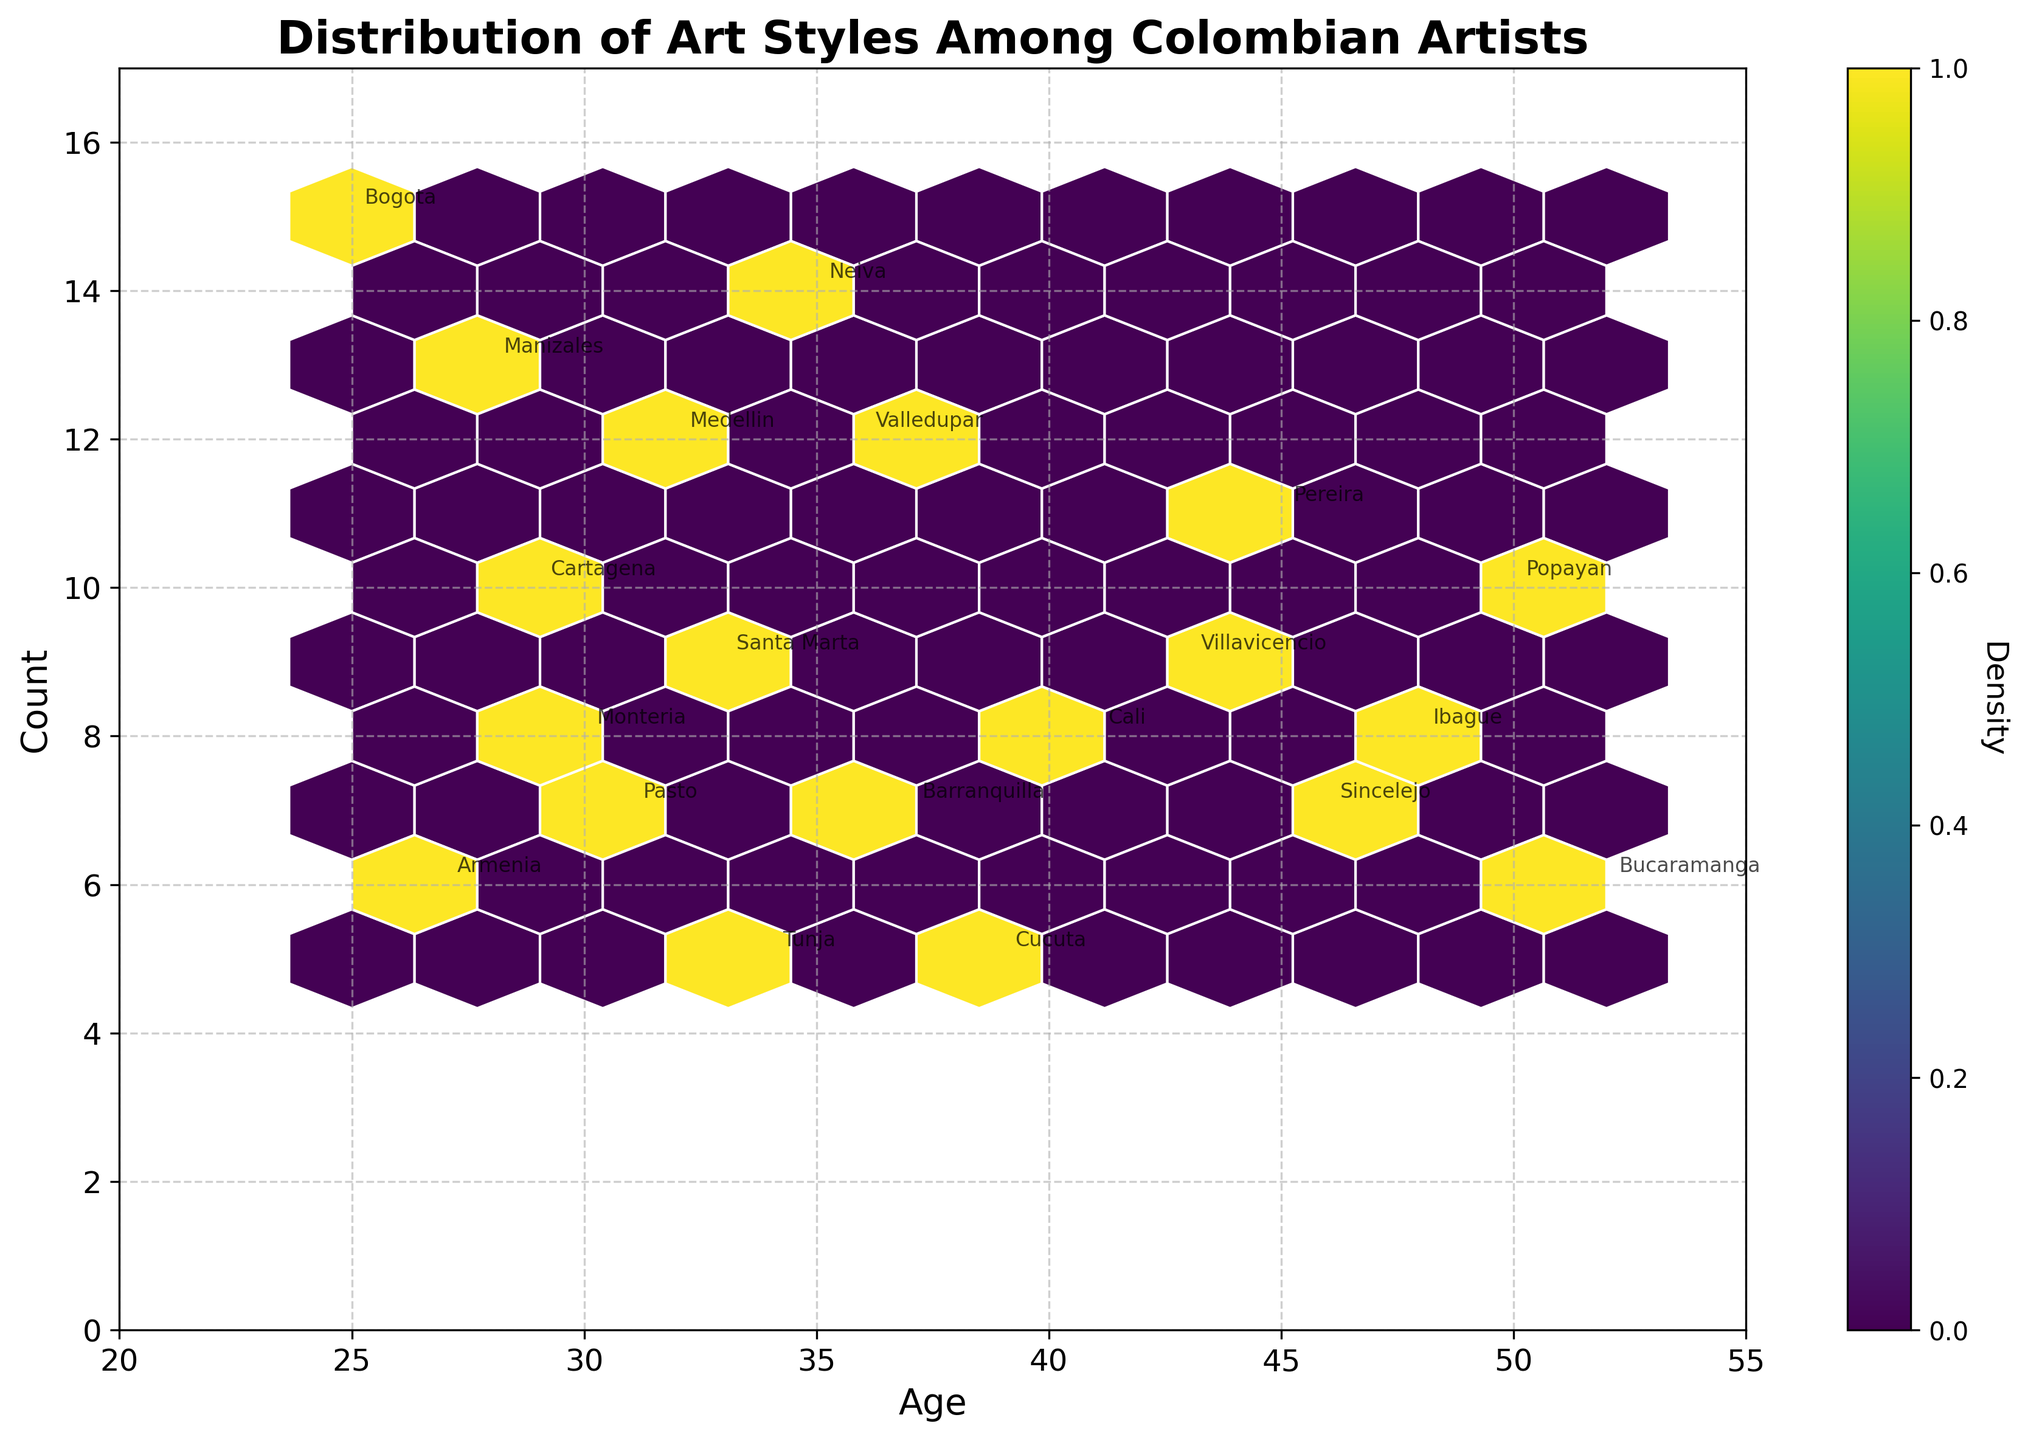What is the title of the hexbin plot? The title of the plot is clearly stated at the top of the figure.
Answer: Distribution of Art Styles Among Colombian Artists Which age group appears to have the highest density of artists? The color intensity in the hexbin plot indicates density. The darkest area shows the highest density.
Answer: Ages 25-35 What is the range of the 'Age' axis? The 'Age' axis runs from the minimum to the maximum value shown on the x-axis.
Answer: 20 to 55 In which age range is the 'Expressionism' art style located? To find 'Expressionism', look for the annotated age range related to this style.
Answer: Around age 37 Which city has the highest number of 'Minimalism' artists and how many are there? Find the 'Minimalism' style and its corresponding city annotation.
Answer: Bucaramanga with 6 artists Which region shows the highest count of artists aged 28? Identify the region annotated nearest to age 28 on the x-axis.
Answer: Manizales Is the distribution of artists homogeneously spread across all ages? Examine the density spread across the hexbin plot.
Answer: No, there is a higher density among younger artists How many art styles are represented in the figure? Count the number of unique annotations representing different art styles.
Answer: 20 